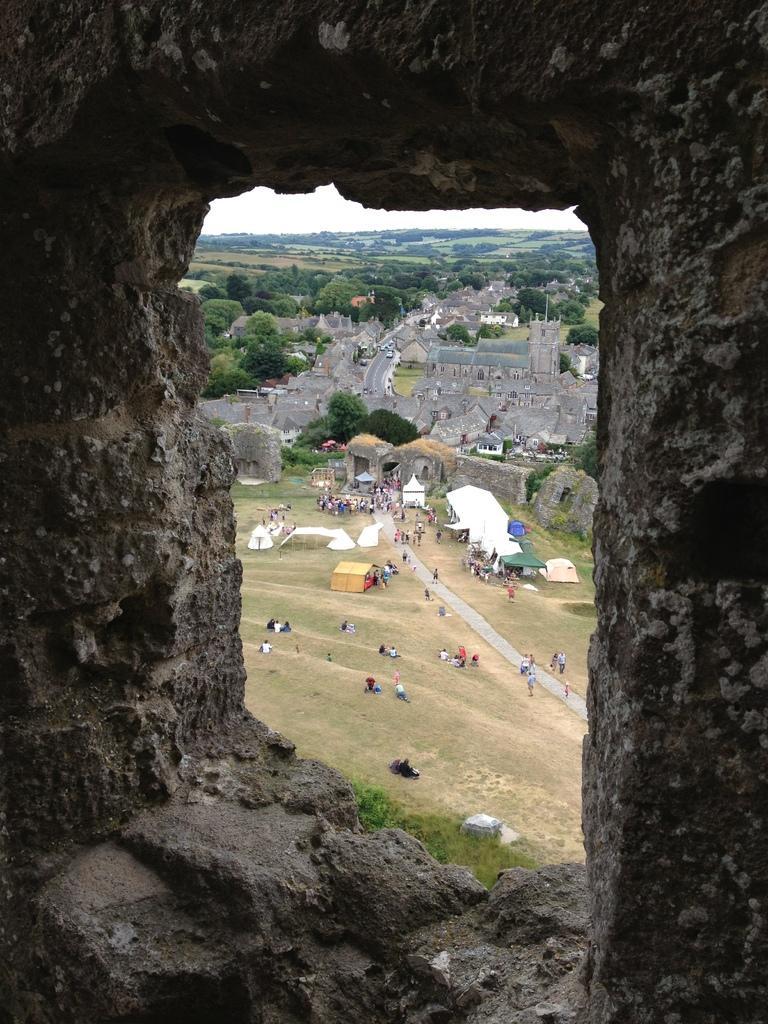Could you give a brief overview of what you see in this image? In the foreground I can see a cave like wall, crowd, tents and buildings. In the background I can see trees, mountains, vehicles on the road and the sky. This image is taken during a day. 